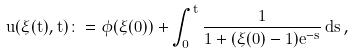Convert formula to latex. <formula><loc_0><loc_0><loc_500><loc_500>u ( \xi ( t ) , t ) \colon = \phi ( \xi ( 0 ) ) + \int _ { 0 } ^ { t } \frac { 1 } { 1 + ( \xi ( 0 ) - 1 ) e ^ { - s } } \, d s \, ,</formula> 